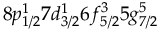<formula> <loc_0><loc_0><loc_500><loc_500>8 p _ { 1 / 2 } ^ { 1 } 7 d _ { 3 / 2 } ^ { 1 } 6 f _ { 5 / 2 } ^ { 3 } 5 g _ { 7 / 2 } ^ { 5 }</formula> 